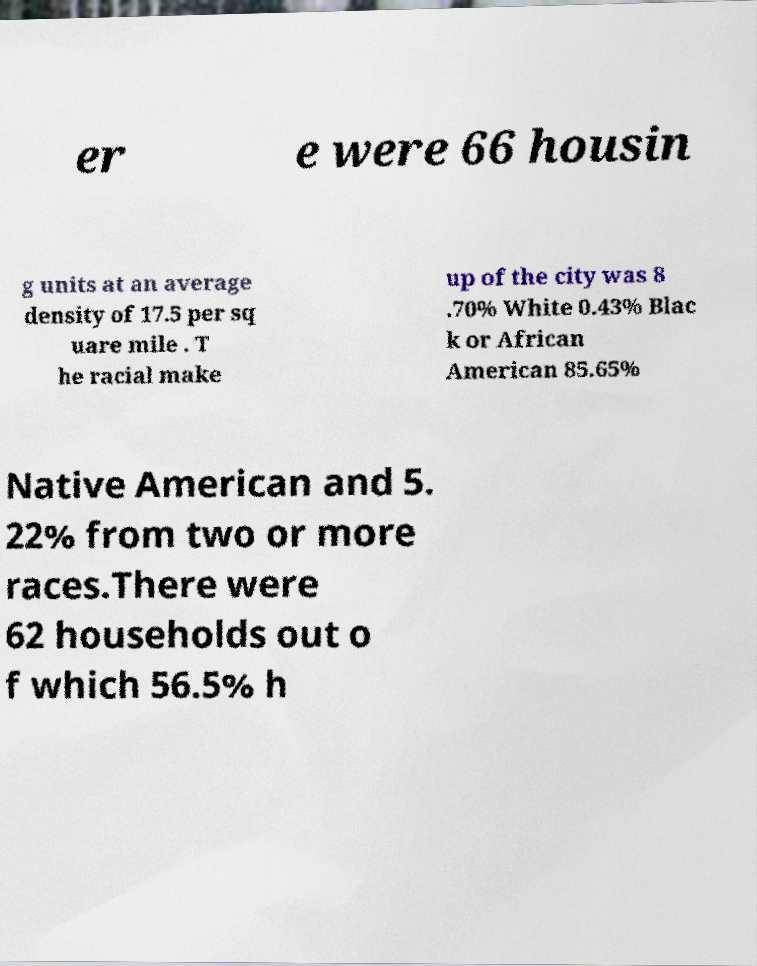Could you assist in decoding the text presented in this image and type it out clearly? er e were 66 housin g units at an average density of 17.5 per sq uare mile . T he racial make up of the city was 8 .70% White 0.43% Blac k or African American 85.65% Native American and 5. 22% from two or more races.There were 62 households out o f which 56.5% h 